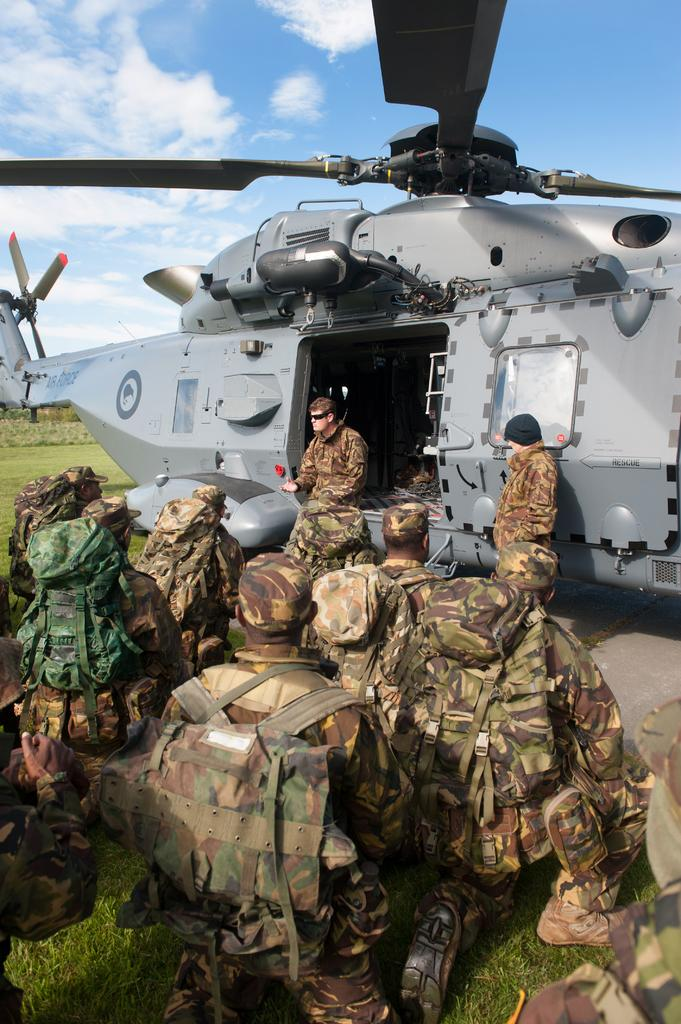How many people are in the image? There is a group of people in the image, but the exact number is not specified. What are the people wearing in the image? The people are wearing bags in the image. What can be seen in the background of the image? There is grass visible in the background of the image. What is the main subject of the image? The main subject of the image is a group of people wearing bags. What type of wine is being served on the airplane in the image? There is no airplane serving wine in the image; it only shows a group of people wearing bags. 